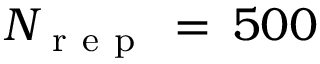<formula> <loc_0><loc_0><loc_500><loc_500>N _ { r e p } \, = \, 5 0 0</formula> 